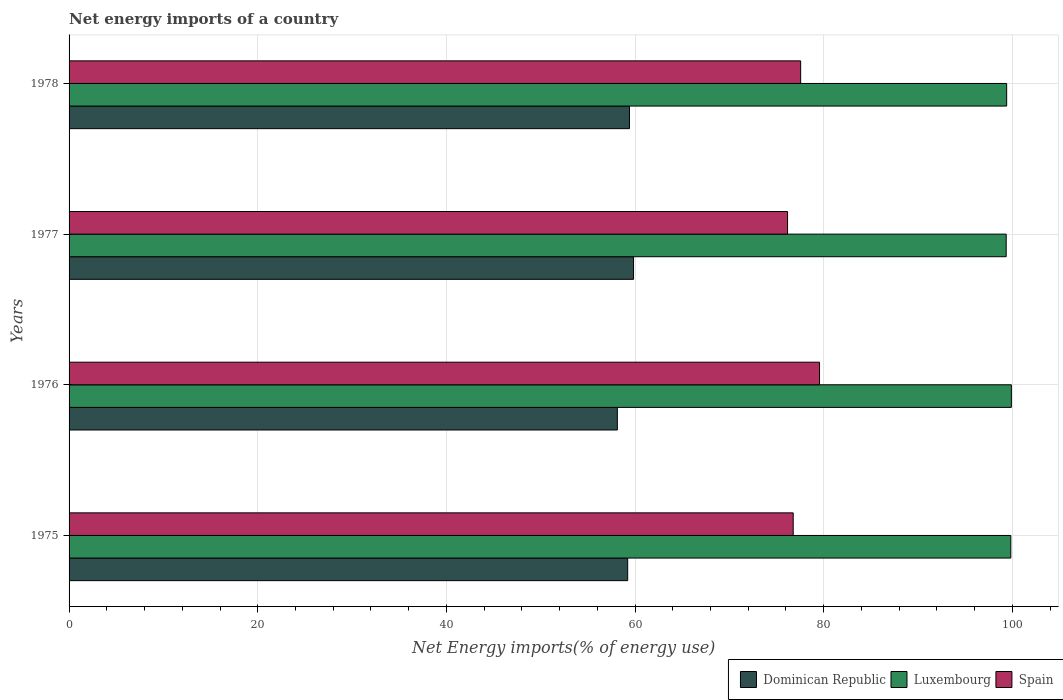How many different coloured bars are there?
Make the answer very short. 3. How many groups of bars are there?
Ensure brevity in your answer.  4. Are the number of bars on each tick of the Y-axis equal?
Offer a very short reply. Yes. How many bars are there on the 3rd tick from the bottom?
Provide a succinct answer. 3. What is the net energy imports in Spain in 1977?
Offer a terse response. 76.17. Across all years, what is the maximum net energy imports in Luxembourg?
Offer a very short reply. 99.9. Across all years, what is the minimum net energy imports in Luxembourg?
Give a very brief answer. 99.35. In which year was the net energy imports in Spain maximum?
Your answer should be very brief. 1976. What is the total net energy imports in Luxembourg in the graph?
Your response must be concise. 398.48. What is the difference between the net energy imports in Dominican Republic in 1975 and that in 1978?
Your answer should be very brief. -0.19. What is the difference between the net energy imports in Spain in 1977 and the net energy imports in Dominican Republic in 1976?
Your response must be concise. 18.05. What is the average net energy imports in Spain per year?
Provide a succinct answer. 77.51. In the year 1978, what is the difference between the net energy imports in Dominican Republic and net energy imports in Luxembourg?
Make the answer very short. -39.99. What is the ratio of the net energy imports in Dominican Republic in 1976 to that in 1977?
Your answer should be compact. 0.97. Is the difference between the net energy imports in Dominican Republic in 1976 and 1978 greater than the difference between the net energy imports in Luxembourg in 1976 and 1978?
Your response must be concise. No. What is the difference between the highest and the second highest net energy imports in Luxembourg?
Make the answer very short. 0.06. What is the difference between the highest and the lowest net energy imports in Spain?
Keep it short and to the point. 3.39. What does the 2nd bar from the top in 1975 represents?
Your answer should be compact. Luxembourg. What does the 2nd bar from the bottom in 1978 represents?
Offer a terse response. Luxembourg. Is it the case that in every year, the sum of the net energy imports in Spain and net energy imports in Dominican Republic is greater than the net energy imports in Luxembourg?
Ensure brevity in your answer.  Yes. How many bars are there?
Keep it short and to the point. 12. Are all the bars in the graph horizontal?
Make the answer very short. Yes. What is the difference between two consecutive major ticks on the X-axis?
Ensure brevity in your answer.  20. Are the values on the major ticks of X-axis written in scientific E-notation?
Offer a very short reply. No. What is the title of the graph?
Keep it short and to the point. Net energy imports of a country. Does "Bulgaria" appear as one of the legend labels in the graph?
Offer a terse response. No. What is the label or title of the X-axis?
Offer a terse response. Net Energy imports(% of energy use). What is the Net Energy imports(% of energy use) in Dominican Republic in 1975?
Provide a short and direct response. 59.22. What is the Net Energy imports(% of energy use) in Luxembourg in 1975?
Keep it short and to the point. 99.84. What is the Net Energy imports(% of energy use) of Spain in 1975?
Give a very brief answer. 76.77. What is the Net Energy imports(% of energy use) of Dominican Republic in 1976?
Ensure brevity in your answer.  58.12. What is the Net Energy imports(% of energy use) of Luxembourg in 1976?
Provide a succinct answer. 99.9. What is the Net Energy imports(% of energy use) of Spain in 1976?
Offer a terse response. 79.56. What is the Net Energy imports(% of energy use) of Dominican Republic in 1977?
Offer a very short reply. 59.84. What is the Net Energy imports(% of energy use) of Luxembourg in 1977?
Offer a very short reply. 99.35. What is the Net Energy imports(% of energy use) of Spain in 1977?
Give a very brief answer. 76.17. What is the Net Energy imports(% of energy use) of Dominican Republic in 1978?
Provide a short and direct response. 59.41. What is the Net Energy imports(% of energy use) in Luxembourg in 1978?
Make the answer very short. 99.4. What is the Net Energy imports(% of energy use) of Spain in 1978?
Provide a succinct answer. 77.56. Across all years, what is the maximum Net Energy imports(% of energy use) of Dominican Republic?
Offer a terse response. 59.84. Across all years, what is the maximum Net Energy imports(% of energy use) in Luxembourg?
Your answer should be very brief. 99.9. Across all years, what is the maximum Net Energy imports(% of energy use) in Spain?
Your response must be concise. 79.56. Across all years, what is the minimum Net Energy imports(% of energy use) of Dominican Republic?
Ensure brevity in your answer.  58.12. Across all years, what is the minimum Net Energy imports(% of energy use) in Luxembourg?
Your answer should be compact. 99.35. Across all years, what is the minimum Net Energy imports(% of energy use) of Spain?
Offer a very short reply. 76.17. What is the total Net Energy imports(% of energy use) of Dominican Republic in the graph?
Your answer should be very brief. 236.59. What is the total Net Energy imports(% of energy use) in Luxembourg in the graph?
Offer a very short reply. 398.48. What is the total Net Energy imports(% of energy use) in Spain in the graph?
Make the answer very short. 310.06. What is the difference between the Net Energy imports(% of energy use) of Dominican Republic in 1975 and that in 1976?
Offer a very short reply. 1.1. What is the difference between the Net Energy imports(% of energy use) in Luxembourg in 1975 and that in 1976?
Offer a terse response. -0.06. What is the difference between the Net Energy imports(% of energy use) in Spain in 1975 and that in 1976?
Ensure brevity in your answer.  -2.79. What is the difference between the Net Energy imports(% of energy use) in Dominican Republic in 1975 and that in 1977?
Your response must be concise. -0.62. What is the difference between the Net Energy imports(% of energy use) of Luxembourg in 1975 and that in 1977?
Your answer should be very brief. 0.49. What is the difference between the Net Energy imports(% of energy use) in Spain in 1975 and that in 1977?
Provide a succinct answer. 0.6. What is the difference between the Net Energy imports(% of energy use) in Dominican Republic in 1975 and that in 1978?
Ensure brevity in your answer.  -0.19. What is the difference between the Net Energy imports(% of energy use) in Luxembourg in 1975 and that in 1978?
Your response must be concise. 0.44. What is the difference between the Net Energy imports(% of energy use) of Spain in 1975 and that in 1978?
Make the answer very short. -0.79. What is the difference between the Net Energy imports(% of energy use) in Dominican Republic in 1976 and that in 1977?
Provide a short and direct response. -1.72. What is the difference between the Net Energy imports(% of energy use) of Luxembourg in 1976 and that in 1977?
Provide a short and direct response. 0.55. What is the difference between the Net Energy imports(% of energy use) of Spain in 1976 and that in 1977?
Make the answer very short. 3.39. What is the difference between the Net Energy imports(% of energy use) in Dominican Republic in 1976 and that in 1978?
Offer a terse response. -1.29. What is the difference between the Net Energy imports(% of energy use) of Luxembourg in 1976 and that in 1978?
Offer a terse response. 0.5. What is the difference between the Net Energy imports(% of energy use) in Spain in 1976 and that in 1978?
Offer a very short reply. 2. What is the difference between the Net Energy imports(% of energy use) in Dominican Republic in 1977 and that in 1978?
Your answer should be compact. 0.43. What is the difference between the Net Energy imports(% of energy use) of Luxembourg in 1977 and that in 1978?
Make the answer very short. -0.05. What is the difference between the Net Energy imports(% of energy use) of Spain in 1977 and that in 1978?
Offer a very short reply. -1.39. What is the difference between the Net Energy imports(% of energy use) in Dominican Republic in 1975 and the Net Energy imports(% of energy use) in Luxembourg in 1976?
Provide a short and direct response. -40.68. What is the difference between the Net Energy imports(% of energy use) of Dominican Republic in 1975 and the Net Energy imports(% of energy use) of Spain in 1976?
Keep it short and to the point. -20.34. What is the difference between the Net Energy imports(% of energy use) in Luxembourg in 1975 and the Net Energy imports(% of energy use) in Spain in 1976?
Provide a succinct answer. 20.28. What is the difference between the Net Energy imports(% of energy use) in Dominican Republic in 1975 and the Net Energy imports(% of energy use) in Luxembourg in 1977?
Ensure brevity in your answer.  -40.13. What is the difference between the Net Energy imports(% of energy use) of Dominican Republic in 1975 and the Net Energy imports(% of energy use) of Spain in 1977?
Ensure brevity in your answer.  -16.95. What is the difference between the Net Energy imports(% of energy use) in Luxembourg in 1975 and the Net Energy imports(% of energy use) in Spain in 1977?
Provide a succinct answer. 23.67. What is the difference between the Net Energy imports(% of energy use) of Dominican Republic in 1975 and the Net Energy imports(% of energy use) of Luxembourg in 1978?
Your answer should be compact. -40.18. What is the difference between the Net Energy imports(% of energy use) of Dominican Republic in 1975 and the Net Energy imports(% of energy use) of Spain in 1978?
Offer a very short reply. -18.34. What is the difference between the Net Energy imports(% of energy use) of Luxembourg in 1975 and the Net Energy imports(% of energy use) of Spain in 1978?
Ensure brevity in your answer.  22.28. What is the difference between the Net Energy imports(% of energy use) of Dominican Republic in 1976 and the Net Energy imports(% of energy use) of Luxembourg in 1977?
Provide a short and direct response. -41.22. What is the difference between the Net Energy imports(% of energy use) in Dominican Republic in 1976 and the Net Energy imports(% of energy use) in Spain in 1977?
Give a very brief answer. -18.05. What is the difference between the Net Energy imports(% of energy use) of Luxembourg in 1976 and the Net Energy imports(% of energy use) of Spain in 1977?
Your answer should be compact. 23.73. What is the difference between the Net Energy imports(% of energy use) in Dominican Republic in 1976 and the Net Energy imports(% of energy use) in Luxembourg in 1978?
Make the answer very short. -41.27. What is the difference between the Net Energy imports(% of energy use) in Dominican Republic in 1976 and the Net Energy imports(% of energy use) in Spain in 1978?
Your response must be concise. -19.44. What is the difference between the Net Energy imports(% of energy use) in Luxembourg in 1976 and the Net Energy imports(% of energy use) in Spain in 1978?
Provide a succinct answer. 22.34. What is the difference between the Net Energy imports(% of energy use) of Dominican Republic in 1977 and the Net Energy imports(% of energy use) of Luxembourg in 1978?
Give a very brief answer. -39.56. What is the difference between the Net Energy imports(% of energy use) in Dominican Republic in 1977 and the Net Energy imports(% of energy use) in Spain in 1978?
Provide a short and direct response. -17.72. What is the difference between the Net Energy imports(% of energy use) in Luxembourg in 1977 and the Net Energy imports(% of energy use) in Spain in 1978?
Provide a succinct answer. 21.79. What is the average Net Energy imports(% of energy use) of Dominican Republic per year?
Your response must be concise. 59.15. What is the average Net Energy imports(% of energy use) in Luxembourg per year?
Make the answer very short. 99.62. What is the average Net Energy imports(% of energy use) of Spain per year?
Provide a short and direct response. 77.51. In the year 1975, what is the difference between the Net Energy imports(% of energy use) of Dominican Republic and Net Energy imports(% of energy use) of Luxembourg?
Make the answer very short. -40.62. In the year 1975, what is the difference between the Net Energy imports(% of energy use) in Dominican Republic and Net Energy imports(% of energy use) in Spain?
Make the answer very short. -17.55. In the year 1975, what is the difference between the Net Energy imports(% of energy use) in Luxembourg and Net Energy imports(% of energy use) in Spain?
Your answer should be compact. 23.07. In the year 1976, what is the difference between the Net Energy imports(% of energy use) of Dominican Republic and Net Energy imports(% of energy use) of Luxembourg?
Keep it short and to the point. -41.77. In the year 1976, what is the difference between the Net Energy imports(% of energy use) in Dominican Republic and Net Energy imports(% of energy use) in Spain?
Ensure brevity in your answer.  -21.44. In the year 1976, what is the difference between the Net Energy imports(% of energy use) in Luxembourg and Net Energy imports(% of energy use) in Spain?
Your answer should be very brief. 20.34. In the year 1977, what is the difference between the Net Energy imports(% of energy use) of Dominican Republic and Net Energy imports(% of energy use) of Luxembourg?
Give a very brief answer. -39.51. In the year 1977, what is the difference between the Net Energy imports(% of energy use) in Dominican Republic and Net Energy imports(% of energy use) in Spain?
Offer a very short reply. -16.33. In the year 1977, what is the difference between the Net Energy imports(% of energy use) of Luxembourg and Net Energy imports(% of energy use) of Spain?
Give a very brief answer. 23.18. In the year 1978, what is the difference between the Net Energy imports(% of energy use) in Dominican Republic and Net Energy imports(% of energy use) in Luxembourg?
Offer a terse response. -39.99. In the year 1978, what is the difference between the Net Energy imports(% of energy use) in Dominican Republic and Net Energy imports(% of energy use) in Spain?
Make the answer very short. -18.15. In the year 1978, what is the difference between the Net Energy imports(% of energy use) in Luxembourg and Net Energy imports(% of energy use) in Spain?
Your answer should be very brief. 21.84. What is the ratio of the Net Energy imports(% of energy use) of Dominican Republic in 1975 to that in 1976?
Give a very brief answer. 1.02. What is the ratio of the Net Energy imports(% of energy use) of Luxembourg in 1975 to that in 1976?
Ensure brevity in your answer.  1. What is the ratio of the Net Energy imports(% of energy use) of Spain in 1975 to that in 1976?
Provide a succinct answer. 0.96. What is the ratio of the Net Energy imports(% of energy use) of Luxembourg in 1975 to that in 1977?
Offer a terse response. 1. What is the ratio of the Net Energy imports(% of energy use) in Luxembourg in 1975 to that in 1978?
Keep it short and to the point. 1. What is the ratio of the Net Energy imports(% of energy use) of Spain in 1975 to that in 1978?
Offer a terse response. 0.99. What is the ratio of the Net Energy imports(% of energy use) of Dominican Republic in 1976 to that in 1977?
Give a very brief answer. 0.97. What is the ratio of the Net Energy imports(% of energy use) of Spain in 1976 to that in 1977?
Keep it short and to the point. 1.04. What is the ratio of the Net Energy imports(% of energy use) of Dominican Republic in 1976 to that in 1978?
Your answer should be compact. 0.98. What is the ratio of the Net Energy imports(% of energy use) in Luxembourg in 1976 to that in 1978?
Offer a terse response. 1. What is the ratio of the Net Energy imports(% of energy use) in Spain in 1976 to that in 1978?
Offer a very short reply. 1.03. What is the ratio of the Net Energy imports(% of energy use) of Dominican Republic in 1977 to that in 1978?
Make the answer very short. 1.01. What is the ratio of the Net Energy imports(% of energy use) of Spain in 1977 to that in 1978?
Ensure brevity in your answer.  0.98. What is the difference between the highest and the second highest Net Energy imports(% of energy use) in Dominican Republic?
Give a very brief answer. 0.43. What is the difference between the highest and the second highest Net Energy imports(% of energy use) of Luxembourg?
Your answer should be very brief. 0.06. What is the difference between the highest and the second highest Net Energy imports(% of energy use) of Spain?
Your answer should be compact. 2. What is the difference between the highest and the lowest Net Energy imports(% of energy use) in Dominican Republic?
Your answer should be very brief. 1.72. What is the difference between the highest and the lowest Net Energy imports(% of energy use) of Luxembourg?
Offer a terse response. 0.55. What is the difference between the highest and the lowest Net Energy imports(% of energy use) in Spain?
Provide a short and direct response. 3.39. 